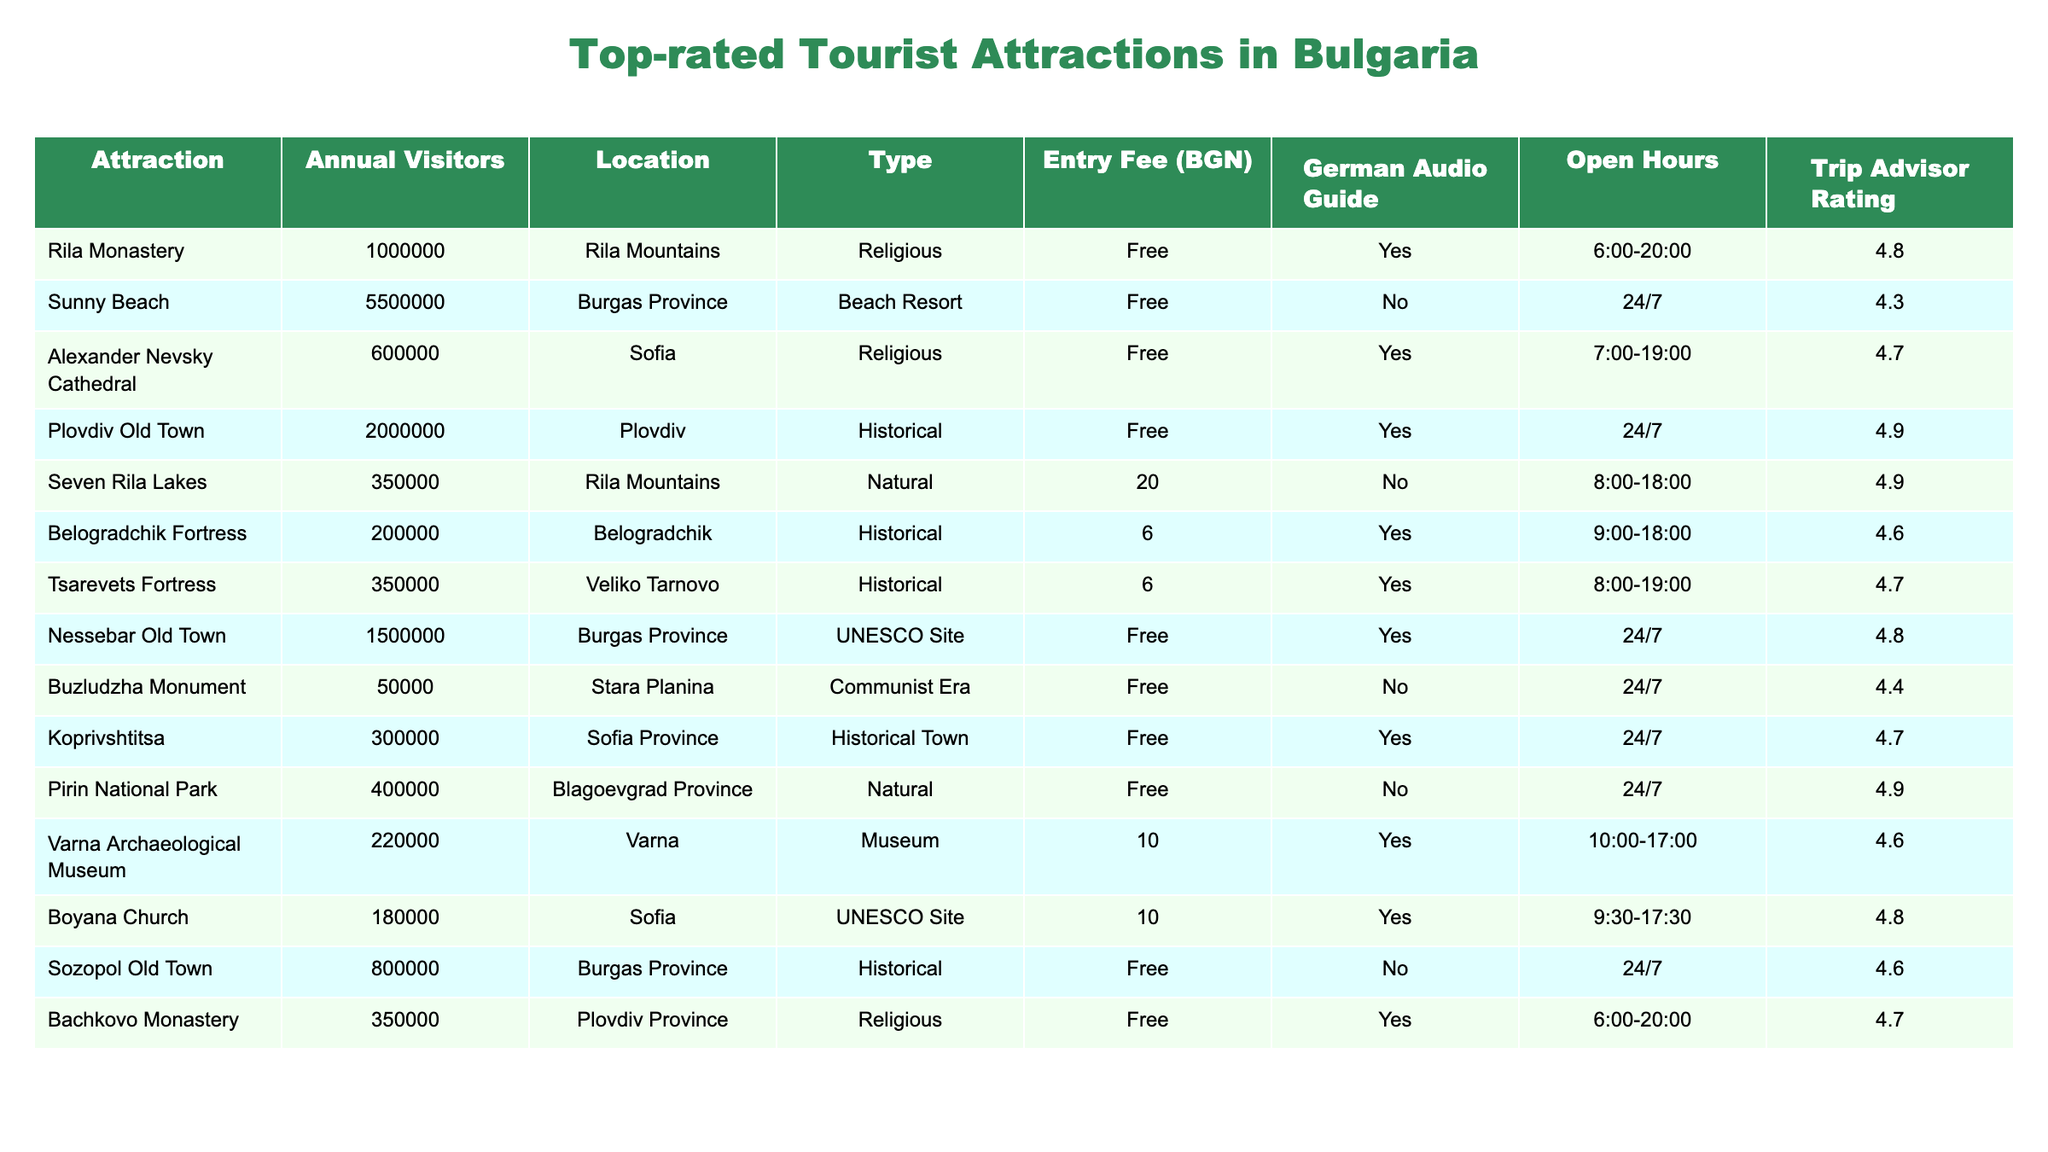What is the most visited tourist attraction in Bulgaria? The table shows that "Sunny Beach" has the highest annual visitors, with 5,500,000.
Answer: Sunny Beach Which attraction has an entry fee of 10 BGN? The table indicates that "Varna Archaeological Museum" and "Boyana Church" both have an entry fee of 10 BGN.
Answer: Varna Archaeological Museum and Boyana Church How many annual visitors does the Rila Monastery have? According to the table, the Rila Monastery has 1,000,000 annual visitors.
Answer: 1,000,000 What is the average number of visitors for attractions in the Rila Mountains? The Rila Monastery has 1,000,000 visitors, and the Seven Rila Lakes has 350,000 visitors. So, (1,000,000 + 350,000) / 2 = 675,000 visitors on average.
Answer: 675,000 Is there a German audio guide available for the Sozopol Old Town? The table shows that there is no German audio guide available for Sozopol Old Town, as indicated by the "No" value under that column.
Answer: No What is the Trip Advisor rating of the Seven Rila Lakes? The table lists the Trip Advisor rating for the Seven Rila Lakes as 4.9.
Answer: 4.9 Which location has the highest Trip Advisor rating, and how many visitors does it have? The highest Trip Advisor rating is 4.9, shared by Plovdiv Old Town and the Seven Rila Lakes, with 2,000,000 and 350,000 visitors respectively.
Answer: Plovdiv Old Town (2,000,000 visitors) and Seven Rila Lakes (350,000 visitors) How many attractions listed have an entry fee greater than 0 BGN? The table shows that there are two attractions with an entry fee: "Seven Rila Lakes" (20 BGN) and "Belogradchik Fortress" (6 BGN). Therefore, the count is 2.
Answer: 2 Which attractions are classified as "Historical" and what are their visitor numbers? The table identifies the following attractions as "Historical": Plovdiv Old Town (2,000,000), Belogradchik Fortress (200,000), Tsarevets Fortress (350,000), Koprivshtitsa (300,000), and Sozopol Old Town (800,000).
Answer: Plovdiv Old Town (2,000,000), Belogradchik Fortress (200,000), Tsarevets Fortress (350,000), Koprivshtitsa (300,000), Sozopol Old Town (800,000) What is the total number of visitors for all attractions in Burgas Province? In Burgas Province, there are three attractions: Sunny Beach (5,500,000), Nessebar Old Town (1,500,000), and Sozopol Old Town (800,000). The total is 5,500,000 + 1,500,000 + 800,000 = 7,800,000 visitors.
Answer: 7,800,000 